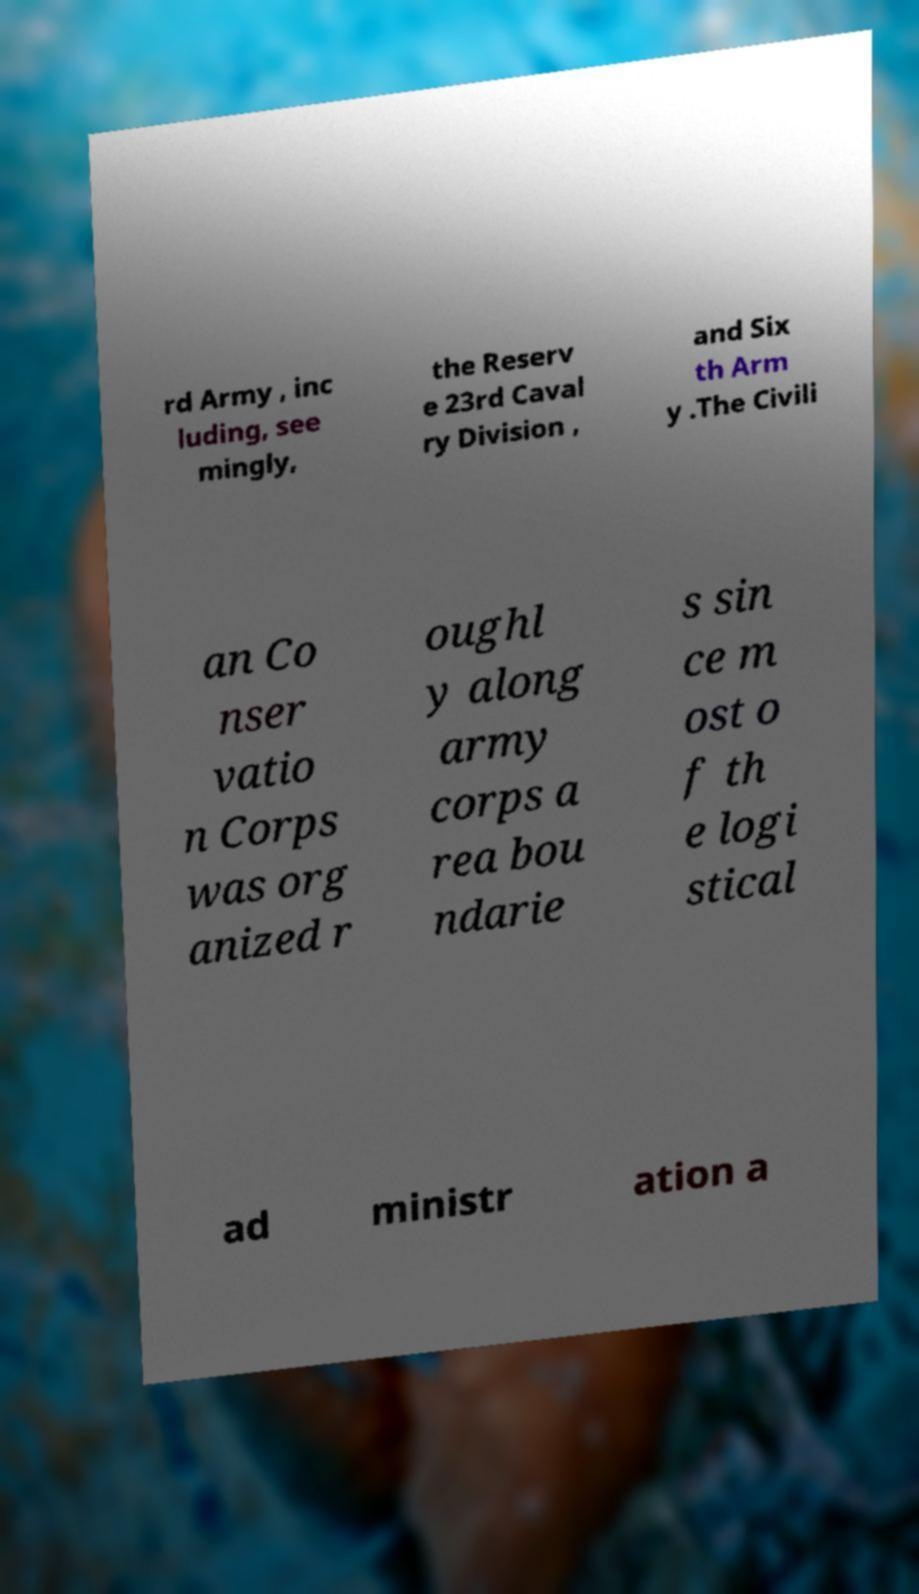Can you accurately transcribe the text from the provided image for me? rd Army , inc luding, see mingly, the Reserv e 23rd Caval ry Division , and Six th Arm y .The Civili an Co nser vatio n Corps was org anized r oughl y along army corps a rea bou ndarie s sin ce m ost o f th e logi stical ad ministr ation a 